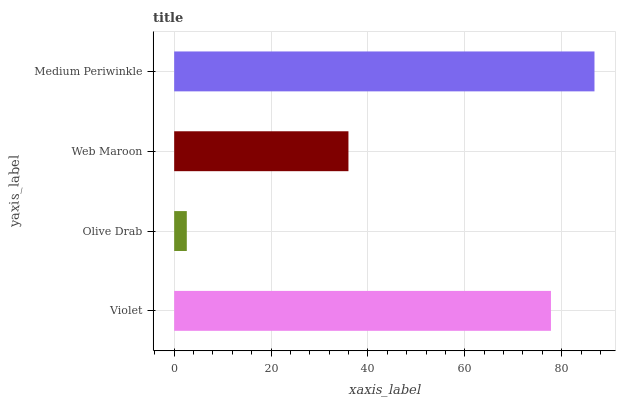Is Olive Drab the minimum?
Answer yes or no. Yes. Is Medium Periwinkle the maximum?
Answer yes or no. Yes. Is Web Maroon the minimum?
Answer yes or no. No. Is Web Maroon the maximum?
Answer yes or no. No. Is Web Maroon greater than Olive Drab?
Answer yes or no. Yes. Is Olive Drab less than Web Maroon?
Answer yes or no. Yes. Is Olive Drab greater than Web Maroon?
Answer yes or no. No. Is Web Maroon less than Olive Drab?
Answer yes or no. No. Is Violet the high median?
Answer yes or no. Yes. Is Web Maroon the low median?
Answer yes or no. Yes. Is Olive Drab the high median?
Answer yes or no. No. Is Violet the low median?
Answer yes or no. No. 